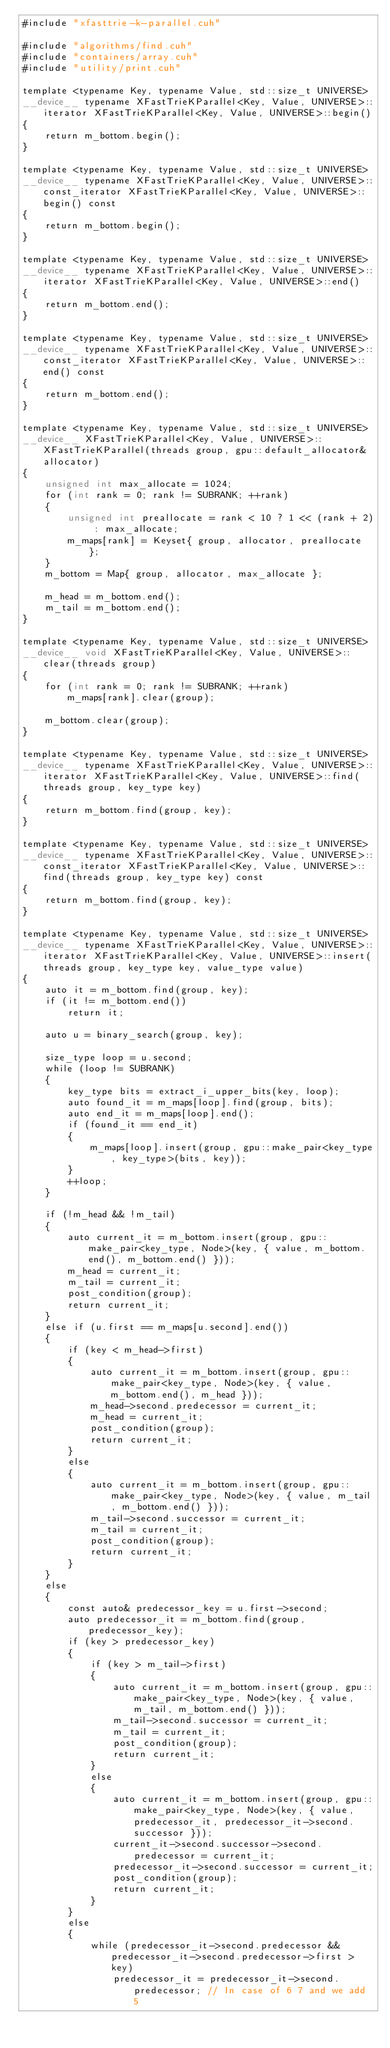Convert code to text. <code><loc_0><loc_0><loc_500><loc_500><_Cuda_>#include "xfasttrie-k-parallel.cuh"

#include "algorithms/find.cuh"
#include "containers/array.cuh"
#include "utility/print.cuh"

template <typename Key, typename Value, std::size_t UNIVERSE>
__device__ typename XFastTrieKParallel<Key, Value, UNIVERSE>::iterator XFastTrieKParallel<Key, Value, UNIVERSE>::begin()
{
	return m_bottom.begin();
}

template <typename Key, typename Value, std::size_t UNIVERSE>
__device__ typename XFastTrieKParallel<Key, Value, UNIVERSE>::const_iterator XFastTrieKParallel<Key, Value, UNIVERSE>::begin() const
{
	return m_bottom.begin();
}

template <typename Key, typename Value, std::size_t UNIVERSE>
__device__ typename XFastTrieKParallel<Key, Value, UNIVERSE>::iterator XFastTrieKParallel<Key, Value, UNIVERSE>::end()
{
	return m_bottom.end();
}

template <typename Key, typename Value, std::size_t UNIVERSE>
__device__ typename XFastTrieKParallel<Key, Value, UNIVERSE>::const_iterator XFastTrieKParallel<Key, Value, UNIVERSE>::end() const
{
	return m_bottom.end();
}

template <typename Key, typename Value, std::size_t UNIVERSE>
__device__ XFastTrieKParallel<Key, Value, UNIVERSE>::XFastTrieKParallel(threads group, gpu::default_allocator& allocator)
{
	unsigned int max_allocate = 1024;
	for (int rank = 0; rank != SUBRANK; ++rank)
	{
		unsigned int preallocate = rank < 10 ? 1 << (rank + 2) : max_allocate;
		m_maps[rank] = Keyset{ group, allocator, preallocate };
	}
	m_bottom = Map{ group, allocator, max_allocate };

	m_head = m_bottom.end();
	m_tail = m_bottom.end();
}

template <typename Key, typename Value, std::size_t UNIVERSE>
__device__ void XFastTrieKParallel<Key, Value, UNIVERSE>::clear(threads group)
{
	for (int rank = 0; rank != SUBRANK; ++rank)
		m_maps[rank].clear(group);

	m_bottom.clear(group);
}

template <typename Key, typename Value, std::size_t UNIVERSE>
__device__ typename XFastTrieKParallel<Key, Value, UNIVERSE>::iterator XFastTrieKParallel<Key, Value, UNIVERSE>::find(threads group, key_type key)
{
	return m_bottom.find(group, key);
}

template <typename Key, typename Value, std::size_t UNIVERSE>
__device__ typename XFastTrieKParallel<Key, Value, UNIVERSE>::const_iterator XFastTrieKParallel<Key, Value, UNIVERSE>::find(threads group, key_type key) const
{
	return m_bottom.find(group, key);
}

template <typename Key, typename Value, std::size_t UNIVERSE>
__device__ typename XFastTrieKParallel<Key, Value, UNIVERSE>::iterator XFastTrieKParallel<Key, Value, UNIVERSE>::insert(threads group, key_type key, value_type value)
{
	auto it = m_bottom.find(group, key);
	if (it != m_bottom.end())
		return it;

	auto u = binary_search(group, key);

	size_type loop = u.second;
	while (loop != SUBRANK)
	{
		key_type bits = extract_i_upper_bits(key, loop);
		auto found_it = m_maps[loop].find(group, bits);
		auto end_it = m_maps[loop].end();
		if (found_it == end_it)
		{
			m_maps[loop].insert(group, gpu::make_pair<key_type, key_type>(bits, key));
		}
		++loop;
	}

	if (!m_head && !m_tail)
	{
		auto current_it = m_bottom.insert(group, gpu::make_pair<key_type, Node>(key, { value, m_bottom.end(), m_bottom.end() }));
		m_head = current_it;
		m_tail = current_it;
		post_condition(group);
		return current_it;
	}
	else if (u.first == m_maps[u.second].end())
	{
		if (key < m_head->first)
		{
			auto current_it = m_bottom.insert(group, gpu::make_pair<key_type, Node>(key, { value, m_bottom.end(), m_head }));
			m_head->second.predecessor = current_it;
			m_head = current_it;
			post_condition(group);
			return current_it;
		}
		else
		{
			auto current_it = m_bottom.insert(group, gpu::make_pair<key_type, Node>(key, { value, m_tail, m_bottom.end() }));
			m_tail->second.successor = current_it;
			m_tail = current_it;
			post_condition(group);
			return current_it;
		}
	}
	else
	{
		const auto& predecessor_key = u.first->second;
		auto predecessor_it = m_bottom.find(group, predecessor_key);
		if (key > predecessor_key)
		{
			if (key > m_tail->first)
			{
				auto current_it = m_bottom.insert(group, gpu::make_pair<key_type, Node>(key, { value, m_tail, m_bottom.end() }));
				m_tail->second.successor = current_it;
				m_tail = current_it;
				post_condition(group);
				return current_it;
			}
			else
			{
				auto current_it = m_bottom.insert(group, gpu::make_pair<key_type, Node>(key, { value, predecessor_it, predecessor_it->second.successor }));
				current_it->second.successor->second.predecessor = current_it;
				predecessor_it->second.successor = current_it;
				post_condition(group);
				return current_it;
			}
		}
		else
		{
			while (predecessor_it->second.predecessor && predecessor_it->second.predecessor->first > key)
				predecessor_it = predecessor_it->second.predecessor; // In case of 6 7 and we add 5
</code> 